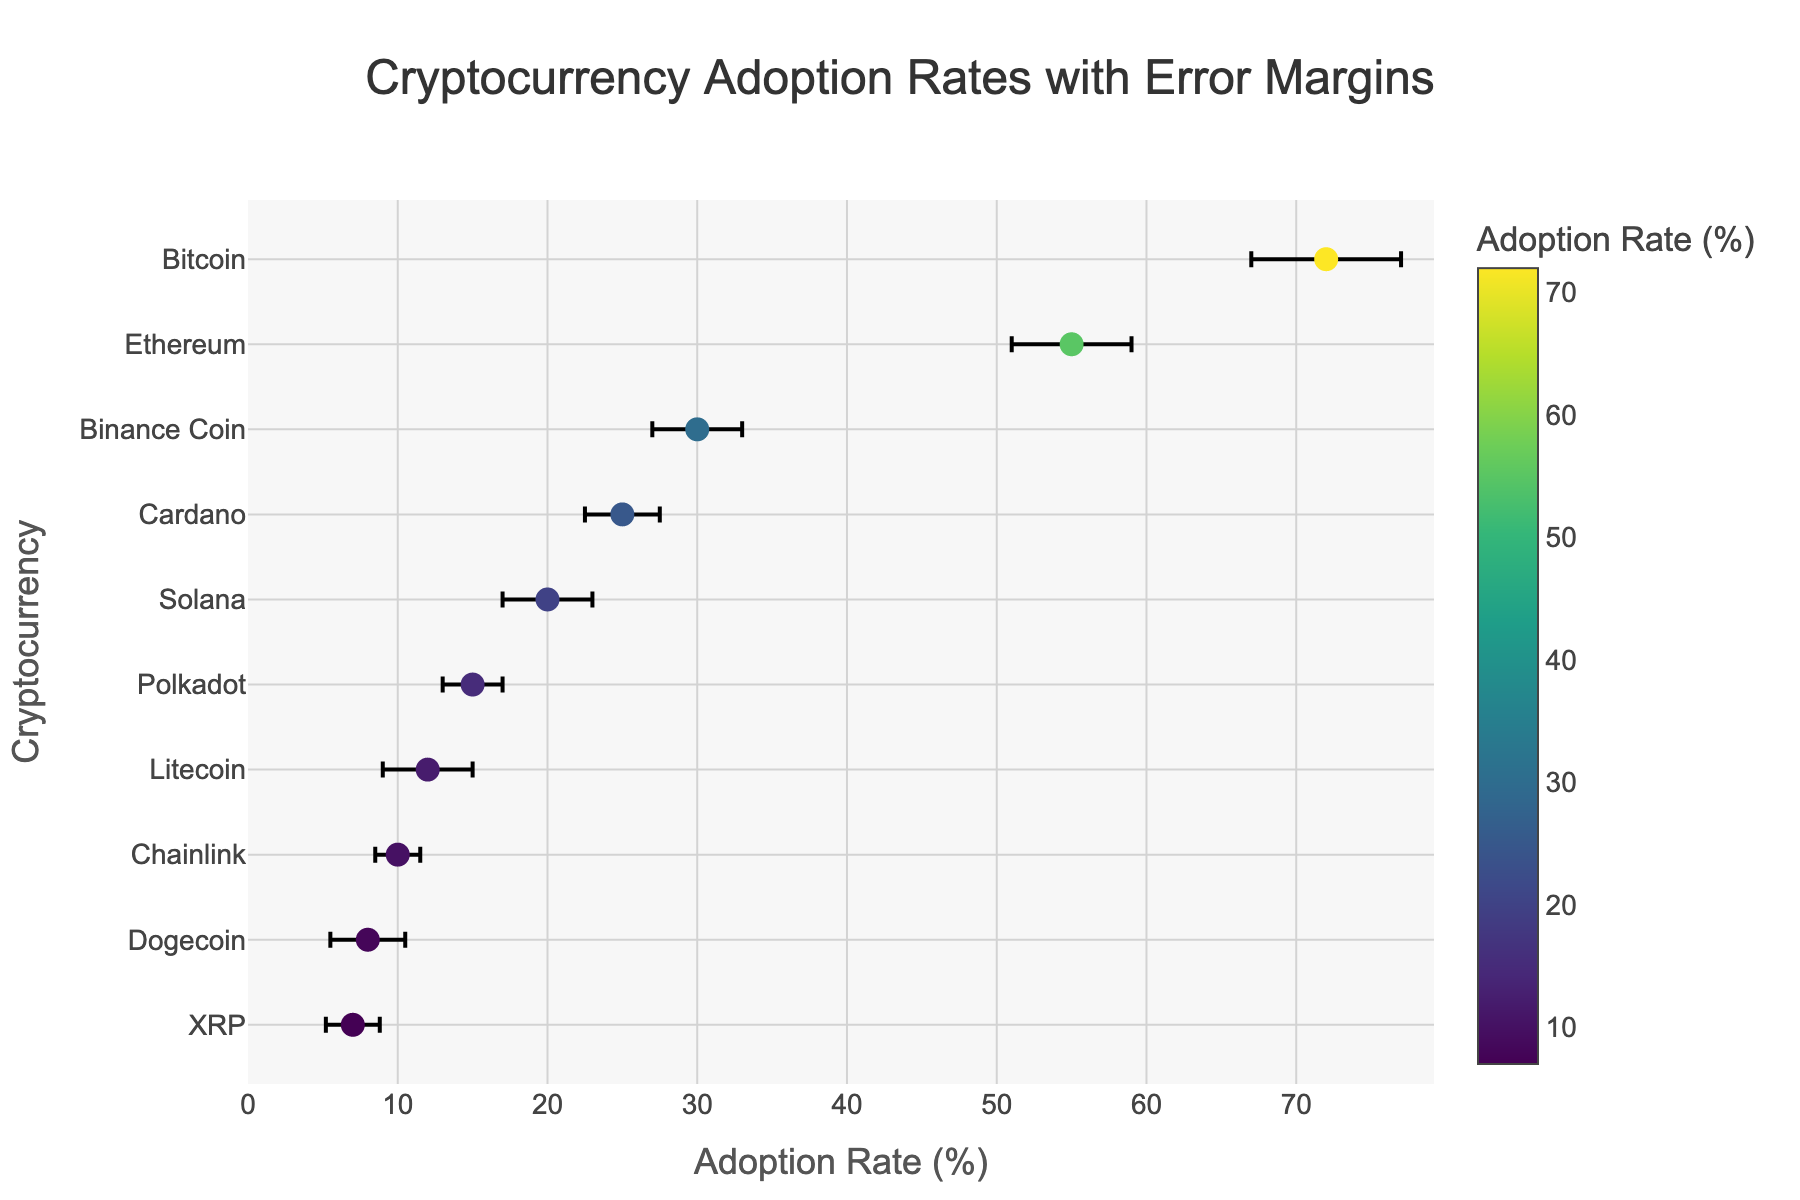Which cryptocurrency has the highest adoption rate? The cryptocurrency with the highest adoption rate is shown at the top of the y-axis with the highest value on the x-axis.
Answer: Bitcoin What is the error margin for Ethereum's adoption rate? The error margin is displayed next to the adoption rate for each cryptocurrency on the x-axis. Look for the error bar length for Ethereum.
Answer: 4% What is the adoption rate of the cryptocurrency with the smallest error margin? Identify the cryptocurrency with the shortest error bar and then check its corresponding adoption rate on the x-axis.
Answer: Chainlink (10%) How do the adoption rates of Bitcoin and Solana compare? Compare the x-axis values for Bitcoin and Solana to see which one is higher and by how much.
Answer: Bitcoin is higher (72% vs. 20%) Which cryptocurrencies have an error margin of 3%? Look for cryptocurrencies with error bars of 3% and note down their names.
Answer: Binance Coin, Solana, Litecoin What is the range of adoption rates for the cryptocurrencies with a margin of error ±2.5%? Identify the cryptocurrencies with an error margin of 2.5% and then determine their adoption rates from the x-axis.
Answer: Cardano (25%) and Dogecoin (8%) What is the title of this figure? The title is displayed at the top center of the figure.
Answer: Cryptocurrency Adoption Rates with Error Margins Which cryptocurrency has the second lowest adoption rate and what is it? Order the adoption rates in increasing order and identify the second lowest.
Answer: XRP (7%) What average error margin is shown on the figure for all cryptocurrencies? Sum all the error margins and divide by the number of data points to find the average.
Answer: 24.3% divided by 10 = 2.43% If the adoption rate of Ethereum increased by 10%, what would its new value be? Add 10% to the current adoption rate of Ethereum.
Answer: 55% + 10% = 65% 